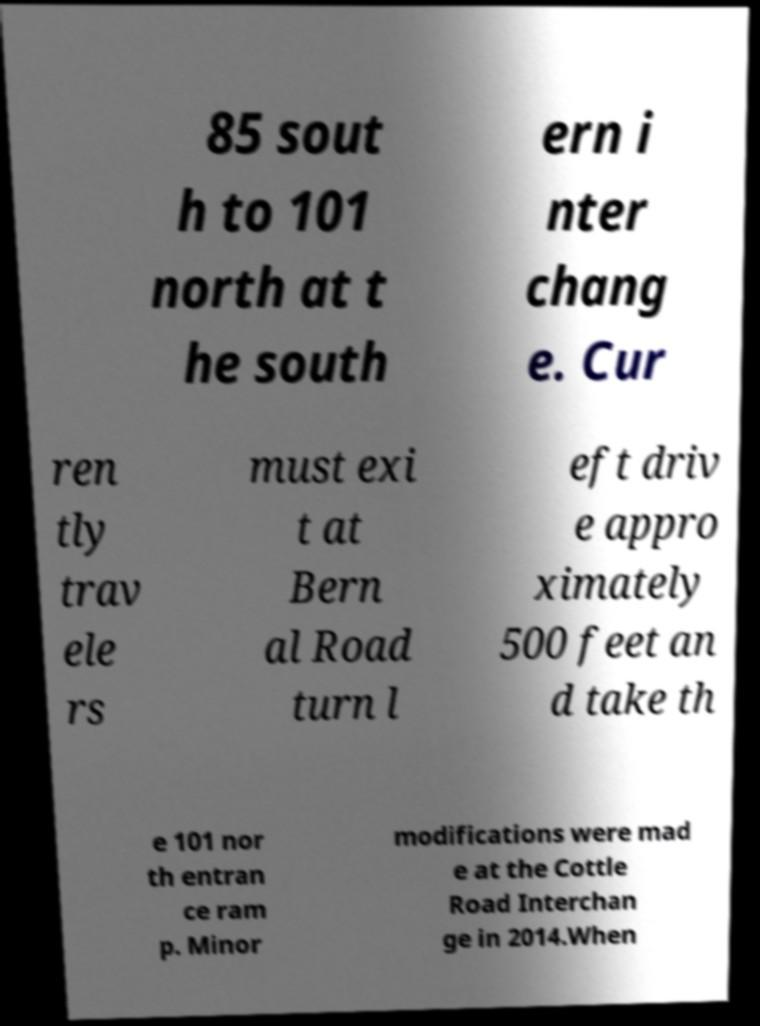What messages or text are displayed in this image? I need them in a readable, typed format. 85 sout h to 101 north at t he south ern i nter chang e. Cur ren tly trav ele rs must exi t at Bern al Road turn l eft driv e appro ximately 500 feet an d take th e 101 nor th entran ce ram p. Minor modifications were mad e at the Cottle Road Interchan ge in 2014.When 